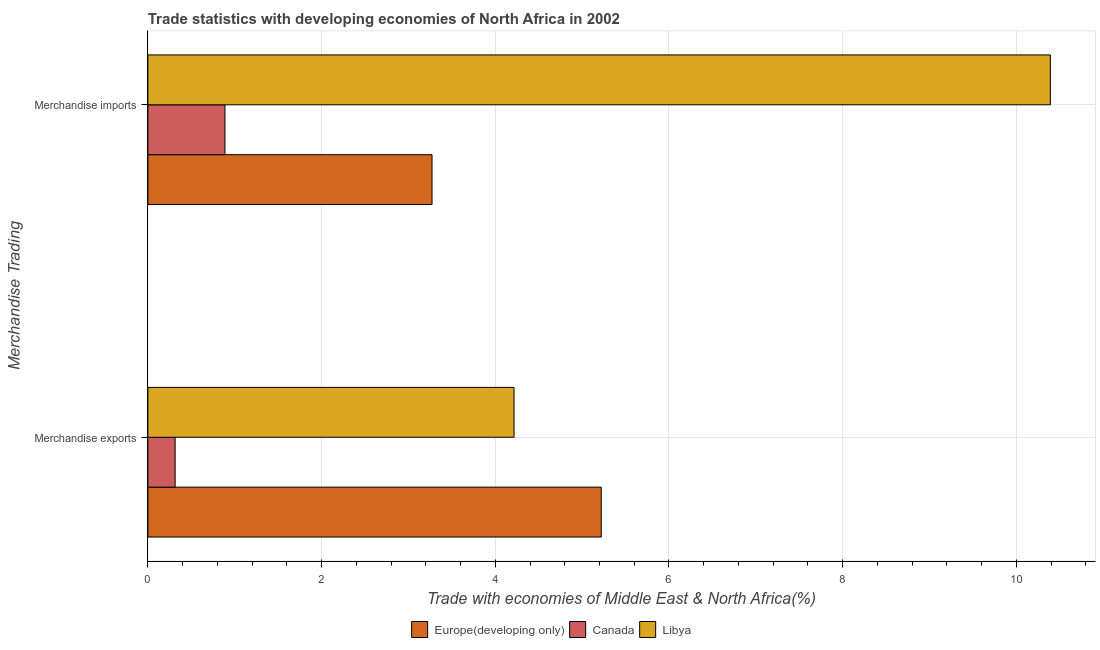How many different coloured bars are there?
Give a very brief answer. 3. How many groups of bars are there?
Provide a short and direct response. 2. How many bars are there on the 1st tick from the bottom?
Your answer should be compact. 3. What is the merchandise imports in Europe(developing only)?
Your answer should be very brief. 3.27. Across all countries, what is the maximum merchandise imports?
Make the answer very short. 10.39. Across all countries, what is the minimum merchandise exports?
Keep it short and to the point. 0.31. In which country was the merchandise imports maximum?
Ensure brevity in your answer.  Libya. What is the total merchandise imports in the graph?
Provide a succinct answer. 14.55. What is the difference between the merchandise imports in Canada and that in Europe(developing only)?
Provide a succinct answer. -2.38. What is the difference between the merchandise exports in Canada and the merchandise imports in Libya?
Make the answer very short. -10.08. What is the average merchandise exports per country?
Make the answer very short. 3.25. What is the difference between the merchandise imports and merchandise exports in Libya?
Ensure brevity in your answer.  6.18. In how many countries, is the merchandise exports greater than 7.6 %?
Keep it short and to the point. 0. What is the ratio of the merchandise imports in Canada to that in Europe(developing only)?
Your response must be concise. 0.27. In how many countries, is the merchandise imports greater than the average merchandise imports taken over all countries?
Ensure brevity in your answer.  1. What does the 1st bar from the top in Merchandise exports represents?
Your response must be concise. Libya. Are all the bars in the graph horizontal?
Your response must be concise. Yes. How many countries are there in the graph?
Provide a succinct answer. 3. Where does the legend appear in the graph?
Provide a succinct answer. Bottom center. How many legend labels are there?
Your answer should be very brief. 3. What is the title of the graph?
Ensure brevity in your answer.  Trade statistics with developing economies of North Africa in 2002. What is the label or title of the X-axis?
Provide a succinct answer. Trade with economies of Middle East & North Africa(%). What is the label or title of the Y-axis?
Provide a succinct answer. Merchandise Trading. What is the Trade with economies of Middle East & North Africa(%) of Europe(developing only) in Merchandise exports?
Your response must be concise. 5.22. What is the Trade with economies of Middle East & North Africa(%) of Canada in Merchandise exports?
Offer a very short reply. 0.31. What is the Trade with economies of Middle East & North Africa(%) of Libya in Merchandise exports?
Provide a succinct answer. 4.22. What is the Trade with economies of Middle East & North Africa(%) of Europe(developing only) in Merchandise imports?
Your answer should be compact. 3.27. What is the Trade with economies of Middle East & North Africa(%) of Canada in Merchandise imports?
Provide a succinct answer. 0.89. What is the Trade with economies of Middle East & North Africa(%) in Libya in Merchandise imports?
Provide a succinct answer. 10.39. Across all Merchandise Trading, what is the maximum Trade with economies of Middle East & North Africa(%) of Europe(developing only)?
Give a very brief answer. 5.22. Across all Merchandise Trading, what is the maximum Trade with economies of Middle East & North Africa(%) of Canada?
Your answer should be compact. 0.89. Across all Merchandise Trading, what is the maximum Trade with economies of Middle East & North Africa(%) of Libya?
Your answer should be compact. 10.39. Across all Merchandise Trading, what is the minimum Trade with economies of Middle East & North Africa(%) of Europe(developing only)?
Offer a very short reply. 3.27. Across all Merchandise Trading, what is the minimum Trade with economies of Middle East & North Africa(%) of Canada?
Make the answer very short. 0.31. Across all Merchandise Trading, what is the minimum Trade with economies of Middle East & North Africa(%) in Libya?
Your answer should be very brief. 4.22. What is the total Trade with economies of Middle East & North Africa(%) in Europe(developing only) in the graph?
Provide a succinct answer. 8.49. What is the total Trade with economies of Middle East & North Africa(%) of Canada in the graph?
Provide a short and direct response. 1.2. What is the total Trade with economies of Middle East & North Africa(%) of Libya in the graph?
Offer a very short reply. 14.61. What is the difference between the Trade with economies of Middle East & North Africa(%) of Europe(developing only) in Merchandise exports and that in Merchandise imports?
Provide a short and direct response. 1.95. What is the difference between the Trade with economies of Middle East & North Africa(%) in Canada in Merchandise exports and that in Merchandise imports?
Your answer should be very brief. -0.57. What is the difference between the Trade with economies of Middle East & North Africa(%) in Libya in Merchandise exports and that in Merchandise imports?
Give a very brief answer. -6.18. What is the difference between the Trade with economies of Middle East & North Africa(%) in Europe(developing only) in Merchandise exports and the Trade with economies of Middle East & North Africa(%) in Canada in Merchandise imports?
Provide a succinct answer. 4.33. What is the difference between the Trade with economies of Middle East & North Africa(%) of Europe(developing only) in Merchandise exports and the Trade with economies of Middle East & North Africa(%) of Libya in Merchandise imports?
Make the answer very short. -5.17. What is the difference between the Trade with economies of Middle East & North Africa(%) in Canada in Merchandise exports and the Trade with economies of Middle East & North Africa(%) in Libya in Merchandise imports?
Provide a succinct answer. -10.08. What is the average Trade with economies of Middle East & North Africa(%) of Europe(developing only) per Merchandise Trading?
Your answer should be very brief. 4.25. What is the average Trade with economies of Middle East & North Africa(%) of Canada per Merchandise Trading?
Provide a succinct answer. 0.6. What is the average Trade with economies of Middle East & North Africa(%) in Libya per Merchandise Trading?
Your answer should be very brief. 7.3. What is the difference between the Trade with economies of Middle East & North Africa(%) of Europe(developing only) and Trade with economies of Middle East & North Africa(%) of Canada in Merchandise exports?
Ensure brevity in your answer.  4.91. What is the difference between the Trade with economies of Middle East & North Africa(%) of Canada and Trade with economies of Middle East & North Africa(%) of Libya in Merchandise exports?
Ensure brevity in your answer.  -3.9. What is the difference between the Trade with economies of Middle East & North Africa(%) of Europe(developing only) and Trade with economies of Middle East & North Africa(%) of Canada in Merchandise imports?
Ensure brevity in your answer.  2.38. What is the difference between the Trade with economies of Middle East & North Africa(%) in Europe(developing only) and Trade with economies of Middle East & North Africa(%) in Libya in Merchandise imports?
Provide a short and direct response. -7.12. What is the difference between the Trade with economies of Middle East & North Africa(%) of Canada and Trade with economies of Middle East & North Africa(%) of Libya in Merchandise imports?
Your answer should be compact. -9.5. What is the ratio of the Trade with economies of Middle East & North Africa(%) of Europe(developing only) in Merchandise exports to that in Merchandise imports?
Keep it short and to the point. 1.6. What is the ratio of the Trade with economies of Middle East & North Africa(%) in Canada in Merchandise exports to that in Merchandise imports?
Give a very brief answer. 0.35. What is the ratio of the Trade with economies of Middle East & North Africa(%) in Libya in Merchandise exports to that in Merchandise imports?
Your answer should be very brief. 0.41. What is the difference between the highest and the second highest Trade with economies of Middle East & North Africa(%) of Europe(developing only)?
Offer a very short reply. 1.95. What is the difference between the highest and the second highest Trade with economies of Middle East & North Africa(%) of Canada?
Provide a short and direct response. 0.57. What is the difference between the highest and the second highest Trade with economies of Middle East & North Africa(%) of Libya?
Give a very brief answer. 6.18. What is the difference between the highest and the lowest Trade with economies of Middle East & North Africa(%) of Europe(developing only)?
Offer a very short reply. 1.95. What is the difference between the highest and the lowest Trade with economies of Middle East & North Africa(%) in Canada?
Keep it short and to the point. 0.57. What is the difference between the highest and the lowest Trade with economies of Middle East & North Africa(%) in Libya?
Keep it short and to the point. 6.18. 